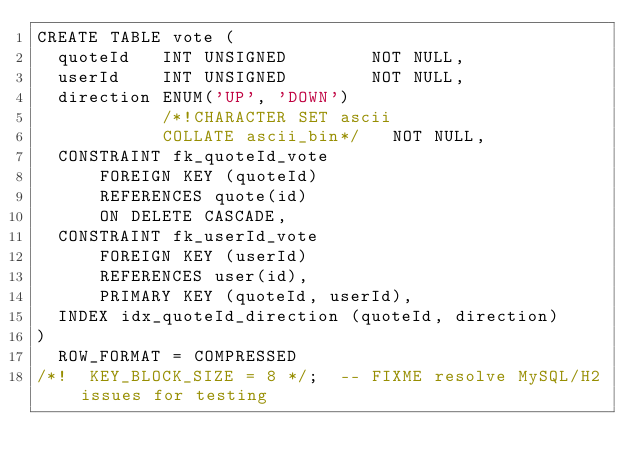Convert code to text. <code><loc_0><loc_0><loc_500><loc_500><_SQL_>CREATE TABLE vote (
  quoteId   INT UNSIGNED        NOT NULL,
  userId    INT UNSIGNED        NOT NULL,
  direction ENUM('UP', 'DOWN')
            /*!CHARACTER SET ascii
            COLLATE ascii_bin*/   NOT NULL,
  CONSTRAINT fk_quoteId_vote
      FOREIGN KEY (quoteId)
      REFERENCES quote(id)
      ON DELETE CASCADE,
  CONSTRAINT fk_userId_vote
      FOREIGN KEY (userId)
      REFERENCES user(id),
      PRIMARY KEY (quoteId, userId),
  INDEX idx_quoteId_direction (quoteId, direction)
)
  ROW_FORMAT = COMPRESSED
/*!  KEY_BLOCK_SIZE = 8 */;  -- FIXME resolve MySQL/H2 issues for testing
</code> 